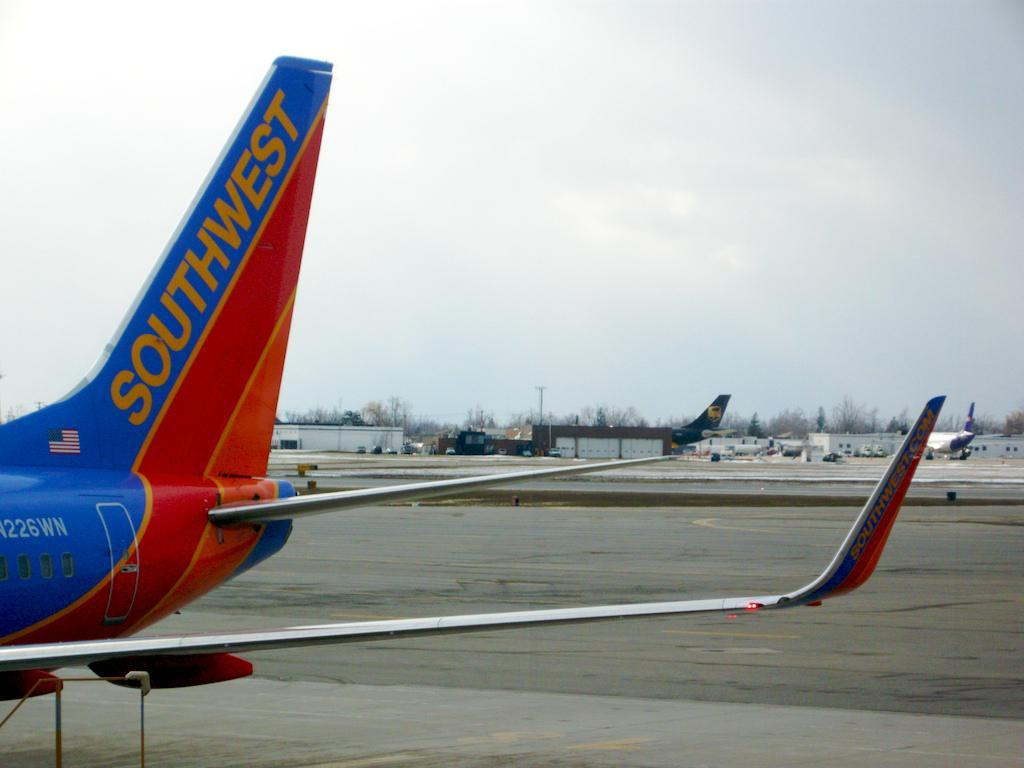What type of vehicles can be seen in the image? There are planes in the image. What type of structures are present in the image? There are houses in the image. What type of natural elements are present in the image? There are trees in the image. What type of utility infrastructure is present in the image? There is a current pole in the image. What is visible in the background of the image? The sky is visible in the image. How many balloons are tied to the current pole in the image? There are no balloons present in the image; it only features planes, houses, trees, a current pole, and the sky. What type of love is depicted in the image? There is no depiction of love in the image; it focuses on planes, houses, trees, a current pole, and the sky. 